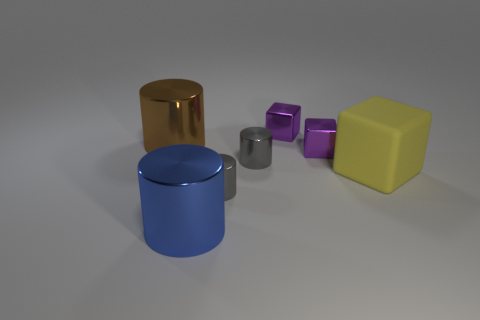Subtract all gray cylinders. How many were subtracted if there are1gray cylinders left? 1 Add 1 small gray metallic cylinders. How many objects exist? 8 Subtract all cylinders. How many objects are left? 3 Subtract all tiny gray balls. Subtract all tiny purple objects. How many objects are left? 5 Add 5 big blocks. How many big blocks are left? 6 Add 6 green spheres. How many green spheres exist? 6 Subtract 1 yellow cubes. How many objects are left? 6 